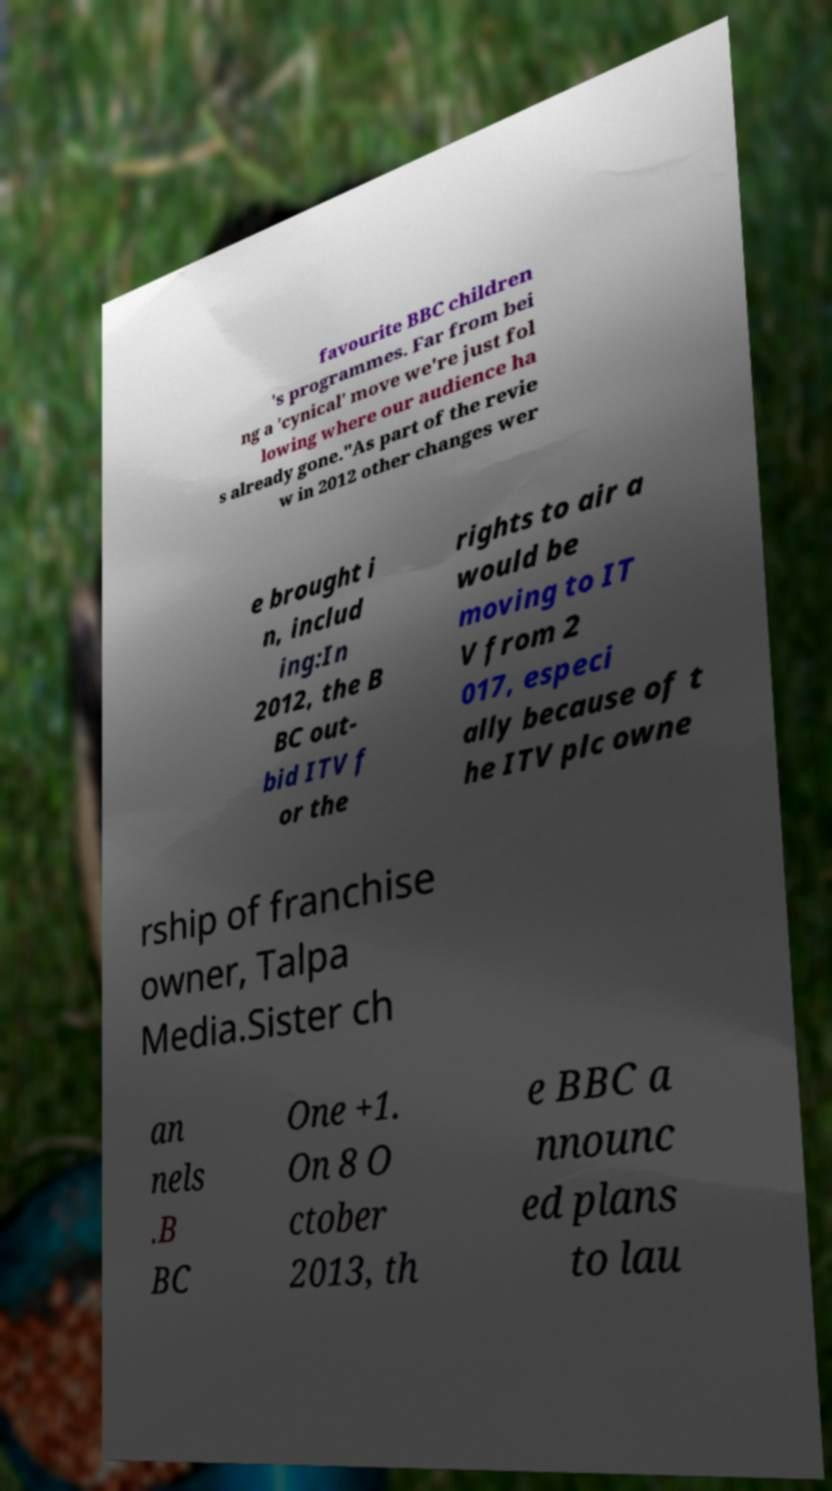For documentation purposes, I need the text within this image transcribed. Could you provide that? favourite BBC children 's programmes. Far from bei ng a 'cynical' move we're just fol lowing where our audience ha s already gone."As part of the revie w in 2012 other changes wer e brought i n, includ ing:In 2012, the B BC out- bid ITV f or the rights to air a would be moving to IT V from 2 017, especi ally because of t he ITV plc owne rship of franchise owner, Talpa Media.Sister ch an nels .B BC One +1. On 8 O ctober 2013, th e BBC a nnounc ed plans to lau 